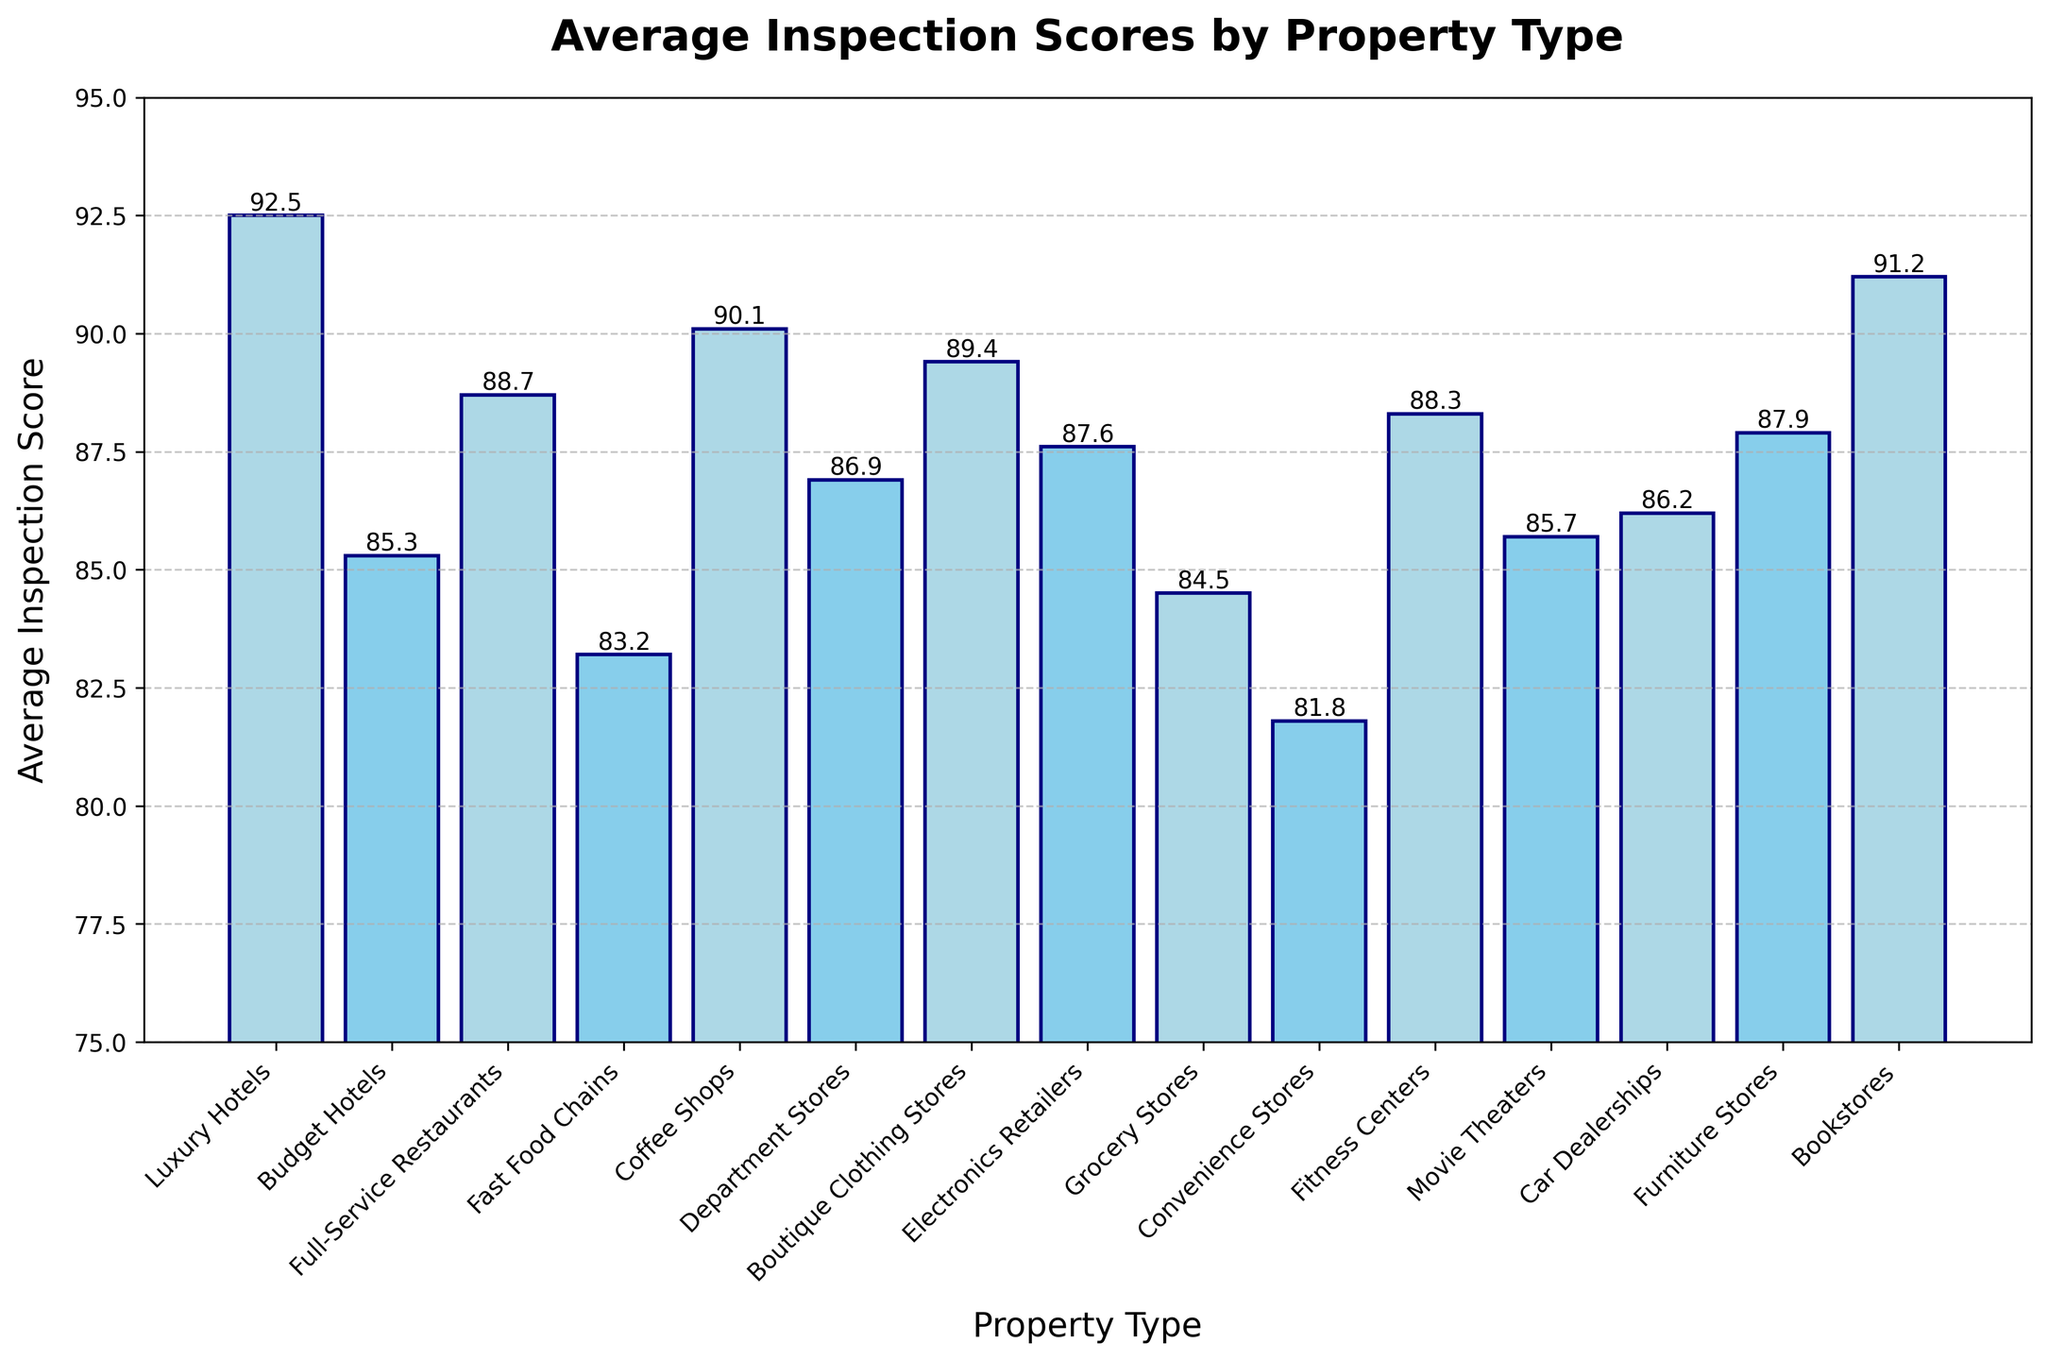Which property type has the highest average inspection score? To find the property type with the highest average inspection score, look for the tallest bar in the bar chart. The Luxury Hotels bar is the tallest.
Answer: Luxury Hotels Which property type has the lowest average inspection score? To find the property type with the lowest average inspection score, identify the shortest bar in the bar chart. The Convenience Stores bar is the shortest.
Answer: Convenience Stores What is the difference in average inspection scores between Luxury Hotels and Fast Food Chains? To calculate the difference, subtract the average inspection score of Fast Food Chains from that of Luxury Hotels: 92.5 - 83.2 = 9.3.
Answer: 9.3 Compare the average inspection score of Full-Service Restaurants to Grocery Stores. Which one is higher, and by how much? Full-Service Restaurants has an average score of 88.7, and Grocery Stores has 84.5. The difference is 88.7 - 84.5 = 4.2. Full-Service Restaurants have a higher score by 4.2 points.
Answer: Full-Service Restaurants, 4.2 Are there any properties with an average inspection score above 90? If so, list them. To find properties with an average score above 90, look for bars that reach or exceed the 90 mark. The properties are Luxury Hotels (92.5) and Bookstores (91.2).
Answer: Luxury Hotels, Bookstores Which property types have an average inspection score between 85 and 90? Identify and list the bars that have heights within the 85 to 90 range. These are Budget Hotels (85.3), Full-Service Restaurants (88.7), Coffee Shops (90.1), Department Stores (86.9), Boutique Clothing Stores (89.4), Electronics Retailers (87.6), Movie Theaters (85.7), Car Dealerships (86.2), and Furniture Stores (87.9).
Answer: Budget Hotels, Full-Service Restaurants, Coffee Shops, Department Stores, Boutique Clothing Stores, Electronics Retailers, Movie Theaters, Car Dealerships, Furniture Stores What is the average of the average inspection scores for Fitness Centers, Movie Theaters, and Furniture Stores? Add the average inspection scores and divide by the number of categories: (88.3 + 85.7 + 87.9) / 3 = 87.3.
Answer: 87.3 Are the average inspection scores for Fast Food Chains and Convenience Stores different? If so, by how much? Compare the scores for Fast Food Chains (83.2) and Convenience Stores (81.8). The difference is 83.2 - 81.8 = 1.4.
Answer: Yes, by 1.4 Does any property type have an average inspection score exactly at 85? To answer this, check if any bar reaches exactly the 85 mark. The bar for Movie Theaters has a score of 85.7, and Budget Hotels has 85.3, but none have exactly 85.
Answer: No 